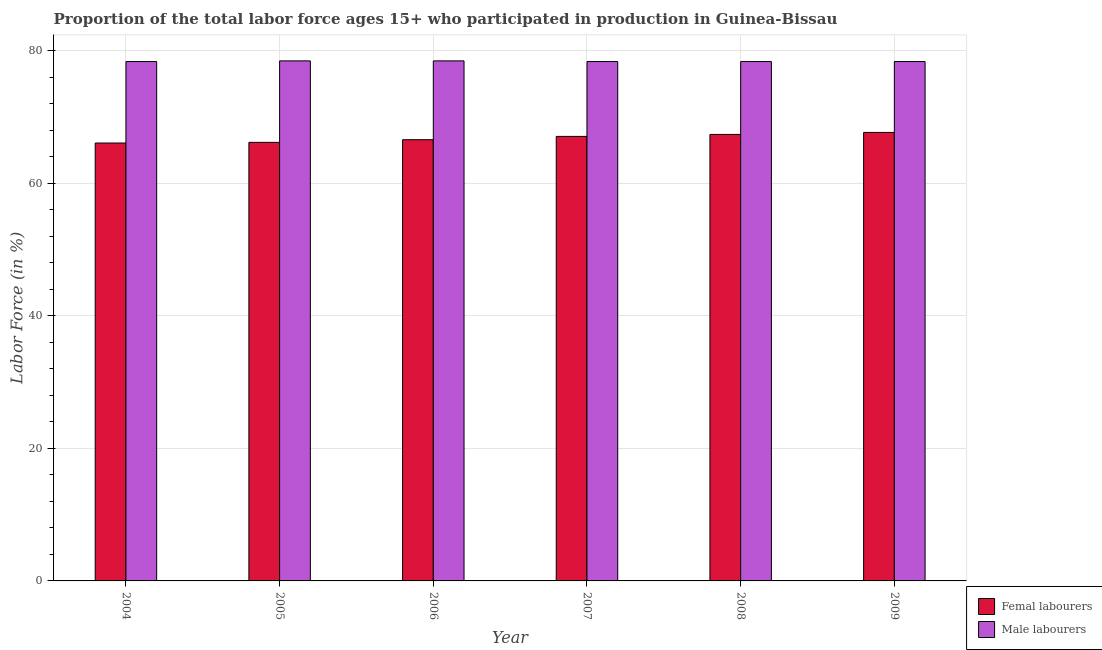How many different coloured bars are there?
Keep it short and to the point. 2. Are the number of bars on each tick of the X-axis equal?
Offer a terse response. Yes. How many bars are there on the 1st tick from the right?
Keep it short and to the point. 2. In how many cases, is the number of bars for a given year not equal to the number of legend labels?
Offer a terse response. 0. What is the percentage of female labor force in 2006?
Offer a terse response. 66.6. Across all years, what is the maximum percentage of female labor force?
Offer a terse response. 67.7. Across all years, what is the minimum percentage of male labour force?
Provide a succinct answer. 78.4. What is the total percentage of female labor force in the graph?
Your answer should be very brief. 401.1. What is the difference between the percentage of female labor force in 2004 and that in 2007?
Your response must be concise. -1. What is the difference between the percentage of female labor force in 2009 and the percentage of male labour force in 2007?
Ensure brevity in your answer.  0.6. What is the average percentage of female labor force per year?
Your answer should be very brief. 66.85. In how many years, is the percentage of female labor force greater than 4 %?
Offer a terse response. 6. What is the ratio of the percentage of male labour force in 2004 to that in 2008?
Keep it short and to the point. 1. Is the percentage of male labour force in 2007 less than that in 2008?
Give a very brief answer. No. What is the difference between the highest and the lowest percentage of male labour force?
Keep it short and to the point. 0.1. In how many years, is the percentage of female labor force greater than the average percentage of female labor force taken over all years?
Your response must be concise. 3. What does the 1st bar from the left in 2007 represents?
Give a very brief answer. Femal labourers. What does the 1st bar from the right in 2006 represents?
Your answer should be compact. Male labourers. Are all the bars in the graph horizontal?
Provide a succinct answer. No. How many years are there in the graph?
Offer a very short reply. 6. What is the difference between two consecutive major ticks on the Y-axis?
Ensure brevity in your answer.  20. Does the graph contain any zero values?
Keep it short and to the point. No. Does the graph contain grids?
Provide a short and direct response. Yes. Where does the legend appear in the graph?
Offer a terse response. Bottom right. How many legend labels are there?
Provide a succinct answer. 2. How are the legend labels stacked?
Ensure brevity in your answer.  Vertical. What is the title of the graph?
Ensure brevity in your answer.  Proportion of the total labor force ages 15+ who participated in production in Guinea-Bissau. Does "Agricultural land" appear as one of the legend labels in the graph?
Your answer should be very brief. No. What is the label or title of the Y-axis?
Provide a succinct answer. Labor Force (in %). What is the Labor Force (in %) in Femal labourers in 2004?
Ensure brevity in your answer.  66.1. What is the Labor Force (in %) in Male labourers in 2004?
Offer a very short reply. 78.4. What is the Labor Force (in %) of Femal labourers in 2005?
Give a very brief answer. 66.2. What is the Labor Force (in %) in Male labourers in 2005?
Make the answer very short. 78.5. What is the Labor Force (in %) of Femal labourers in 2006?
Provide a succinct answer. 66.6. What is the Labor Force (in %) of Male labourers in 2006?
Ensure brevity in your answer.  78.5. What is the Labor Force (in %) in Femal labourers in 2007?
Provide a short and direct response. 67.1. What is the Labor Force (in %) in Male labourers in 2007?
Provide a short and direct response. 78.4. What is the Labor Force (in %) in Femal labourers in 2008?
Keep it short and to the point. 67.4. What is the Labor Force (in %) in Male labourers in 2008?
Offer a very short reply. 78.4. What is the Labor Force (in %) of Femal labourers in 2009?
Your answer should be compact. 67.7. What is the Labor Force (in %) in Male labourers in 2009?
Your answer should be compact. 78.4. Across all years, what is the maximum Labor Force (in %) in Femal labourers?
Offer a terse response. 67.7. Across all years, what is the maximum Labor Force (in %) of Male labourers?
Offer a terse response. 78.5. Across all years, what is the minimum Labor Force (in %) in Femal labourers?
Keep it short and to the point. 66.1. Across all years, what is the minimum Labor Force (in %) of Male labourers?
Offer a terse response. 78.4. What is the total Labor Force (in %) in Femal labourers in the graph?
Offer a terse response. 401.1. What is the total Labor Force (in %) of Male labourers in the graph?
Give a very brief answer. 470.6. What is the difference between the Labor Force (in %) in Male labourers in 2004 and that in 2005?
Your answer should be compact. -0.1. What is the difference between the Labor Force (in %) of Femal labourers in 2004 and that in 2006?
Your response must be concise. -0.5. What is the difference between the Labor Force (in %) of Male labourers in 2004 and that in 2006?
Provide a succinct answer. -0.1. What is the difference between the Labor Force (in %) of Male labourers in 2004 and that in 2008?
Provide a short and direct response. 0. What is the difference between the Labor Force (in %) in Femal labourers in 2004 and that in 2009?
Offer a terse response. -1.6. What is the difference between the Labor Force (in %) in Male labourers in 2004 and that in 2009?
Give a very brief answer. 0. What is the difference between the Labor Force (in %) of Male labourers in 2005 and that in 2007?
Offer a very short reply. 0.1. What is the difference between the Labor Force (in %) in Male labourers in 2005 and that in 2008?
Ensure brevity in your answer.  0.1. What is the difference between the Labor Force (in %) of Male labourers in 2005 and that in 2009?
Your response must be concise. 0.1. What is the difference between the Labor Force (in %) of Femal labourers in 2006 and that in 2009?
Offer a terse response. -1.1. What is the difference between the Labor Force (in %) in Male labourers in 2006 and that in 2009?
Your answer should be very brief. 0.1. What is the difference between the Labor Force (in %) in Femal labourers in 2007 and that in 2009?
Ensure brevity in your answer.  -0.6. What is the difference between the Labor Force (in %) of Femal labourers in 2008 and that in 2009?
Keep it short and to the point. -0.3. What is the difference between the Labor Force (in %) of Femal labourers in 2004 and the Labor Force (in %) of Male labourers in 2005?
Provide a succinct answer. -12.4. What is the difference between the Labor Force (in %) in Femal labourers in 2005 and the Labor Force (in %) in Male labourers in 2009?
Ensure brevity in your answer.  -12.2. What is the difference between the Labor Force (in %) of Femal labourers in 2006 and the Labor Force (in %) of Male labourers in 2007?
Your answer should be compact. -11.8. What is the difference between the Labor Force (in %) in Femal labourers in 2006 and the Labor Force (in %) in Male labourers in 2008?
Give a very brief answer. -11.8. What is the difference between the Labor Force (in %) in Femal labourers in 2006 and the Labor Force (in %) in Male labourers in 2009?
Your response must be concise. -11.8. What is the average Labor Force (in %) of Femal labourers per year?
Offer a very short reply. 66.85. What is the average Labor Force (in %) of Male labourers per year?
Keep it short and to the point. 78.43. In the year 2004, what is the difference between the Labor Force (in %) of Femal labourers and Labor Force (in %) of Male labourers?
Offer a terse response. -12.3. In the year 2008, what is the difference between the Labor Force (in %) of Femal labourers and Labor Force (in %) of Male labourers?
Make the answer very short. -11. In the year 2009, what is the difference between the Labor Force (in %) in Femal labourers and Labor Force (in %) in Male labourers?
Your response must be concise. -10.7. What is the ratio of the Labor Force (in %) in Femal labourers in 2004 to that in 2005?
Make the answer very short. 1. What is the ratio of the Labor Force (in %) in Femal labourers in 2004 to that in 2006?
Make the answer very short. 0.99. What is the ratio of the Labor Force (in %) in Male labourers in 2004 to that in 2006?
Your answer should be very brief. 1. What is the ratio of the Labor Force (in %) of Femal labourers in 2004 to that in 2007?
Provide a short and direct response. 0.99. What is the ratio of the Labor Force (in %) of Male labourers in 2004 to that in 2007?
Your answer should be compact. 1. What is the ratio of the Labor Force (in %) of Femal labourers in 2004 to that in 2008?
Provide a short and direct response. 0.98. What is the ratio of the Labor Force (in %) of Femal labourers in 2004 to that in 2009?
Your answer should be compact. 0.98. What is the ratio of the Labor Force (in %) of Male labourers in 2005 to that in 2006?
Offer a terse response. 1. What is the ratio of the Labor Force (in %) in Femal labourers in 2005 to that in 2007?
Your answer should be compact. 0.99. What is the ratio of the Labor Force (in %) of Male labourers in 2005 to that in 2007?
Your answer should be very brief. 1. What is the ratio of the Labor Force (in %) of Femal labourers in 2005 to that in 2008?
Keep it short and to the point. 0.98. What is the ratio of the Labor Force (in %) in Male labourers in 2005 to that in 2008?
Make the answer very short. 1. What is the ratio of the Labor Force (in %) of Femal labourers in 2005 to that in 2009?
Provide a succinct answer. 0.98. What is the ratio of the Labor Force (in %) in Femal labourers in 2006 to that in 2008?
Provide a succinct answer. 0.99. What is the ratio of the Labor Force (in %) in Male labourers in 2006 to that in 2008?
Offer a very short reply. 1. What is the ratio of the Labor Force (in %) in Femal labourers in 2006 to that in 2009?
Your answer should be very brief. 0.98. What is the ratio of the Labor Force (in %) of Male labourers in 2006 to that in 2009?
Your answer should be compact. 1. What is the ratio of the Labor Force (in %) in Male labourers in 2007 to that in 2008?
Ensure brevity in your answer.  1. What is the ratio of the Labor Force (in %) in Femal labourers in 2007 to that in 2009?
Your answer should be compact. 0.99. What is the ratio of the Labor Force (in %) in Male labourers in 2007 to that in 2009?
Provide a short and direct response. 1. What is the difference between the highest and the second highest Labor Force (in %) of Femal labourers?
Provide a succinct answer. 0.3. What is the difference between the highest and the second highest Labor Force (in %) of Male labourers?
Ensure brevity in your answer.  0. What is the difference between the highest and the lowest Labor Force (in %) in Femal labourers?
Provide a short and direct response. 1.6. 